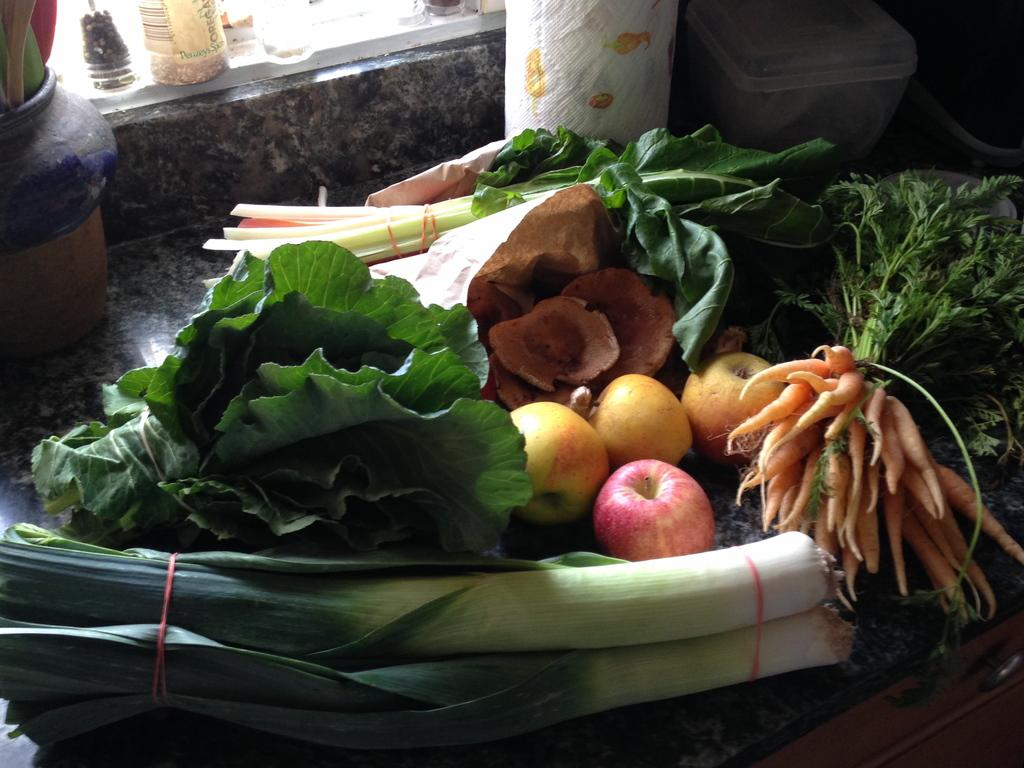What type of food is in the center of the image? There are vegetables in the center of the image, including carrots. What other types of vegetables can be seen in the image? Leafy vegetables are visible in the image. What can be seen in the background of the image? There are boxes and bottles in the background of the image. What type of storage unit is at the bottom of the image? There is a cupboard at the bottom of the image. What type of humor can be seen in the image? There is no humor present in the image; it is a still image of vegetables, boxes, bottles, and a cupboard. How is the glue used in the image? There is no glue present in the image. 